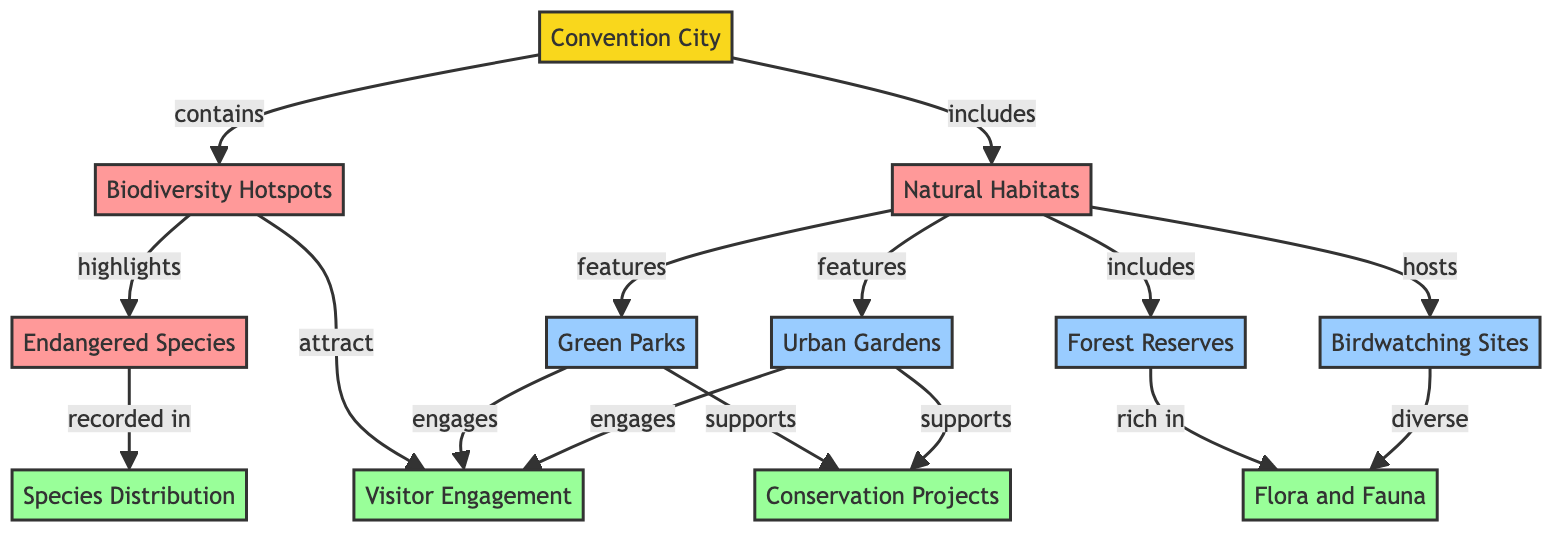What does the convention city contain? The diagram shows that the convention city contains biodiversity hotspots. This can be found by looking at the relationship connecting the "Convention City" node to the "Biodiversity Hotspots" node.
Answer: biodiversity hotspots How many features are listed under natural habitats? The natural habitats encompass four features: Green Parks, Urban Gardens, Forest Reserves, and Birdwatching Sites. By counting these features connected to the "Natural Habitats" node, we can tally up to four.
Answer: 4 Which category highlights endangered species? The diagram indicates that the "Biodiversity Hotspots" category highlights endangered species. This is evident from the direct link that indicates the relationship between these two nodes.
Answer: biodiversity hotspots What supports conservation projects? The features that support conservation projects are Green Parks and Urban Gardens. These are both connected to the "Conservation Projects" node, indicating their supportive role.
Answer: Green Parks, Urban Gardens Which data describes the species distribution? The species distribution is described by the "Species Distribution" data node. This is identified by the connection from the "Endangered Species" category to the relevant data node.
Answer: Species Distribution Do urban gardens engage visitor engagement? Yes, urban gardens engage visitor engagement. This is shown through the direct link from the "Urban Gardens" feature to the "Visitor Engagement" data, indicating their role in engaging visitors.
Answer: Yes What is rich in flora and fauna? The "Forest Reserves" are rich in flora and fauna, as indicated by the respective relationship in the diagram connecting them to the "Flora and Fauna" data node.
Answer: Forest Reserves How many types of habitats are included in the convention city? There are three types of habitats included in the convention city: Green Parks, Urban Gardens, and Forest Reserves. Counting these features that fall under the "Natural Habitats" category gives us three.
Answer: 3 Which feature hosts birdwatching sites? The feature that hosts birdwatching sites is the "Natural Habitats." This relationship is directly connected in the diagram from "Natural Habitats" to "Birdwatching Sites."
Answer: Natural Habitats 